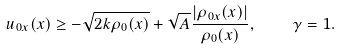<formula> <loc_0><loc_0><loc_500><loc_500>u _ { 0 x } ( x ) \geq - \sqrt { 2 k \rho _ { 0 } ( x ) } + \sqrt { A } \frac { | \rho _ { 0 x } ( x ) | } { \rho _ { 0 } ( x ) } , \quad \gamma = 1 .</formula> 